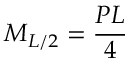Convert formula to latex. <formula><loc_0><loc_0><loc_500><loc_500>M _ { L / 2 } = { \frac { P L } { 4 } }</formula> 